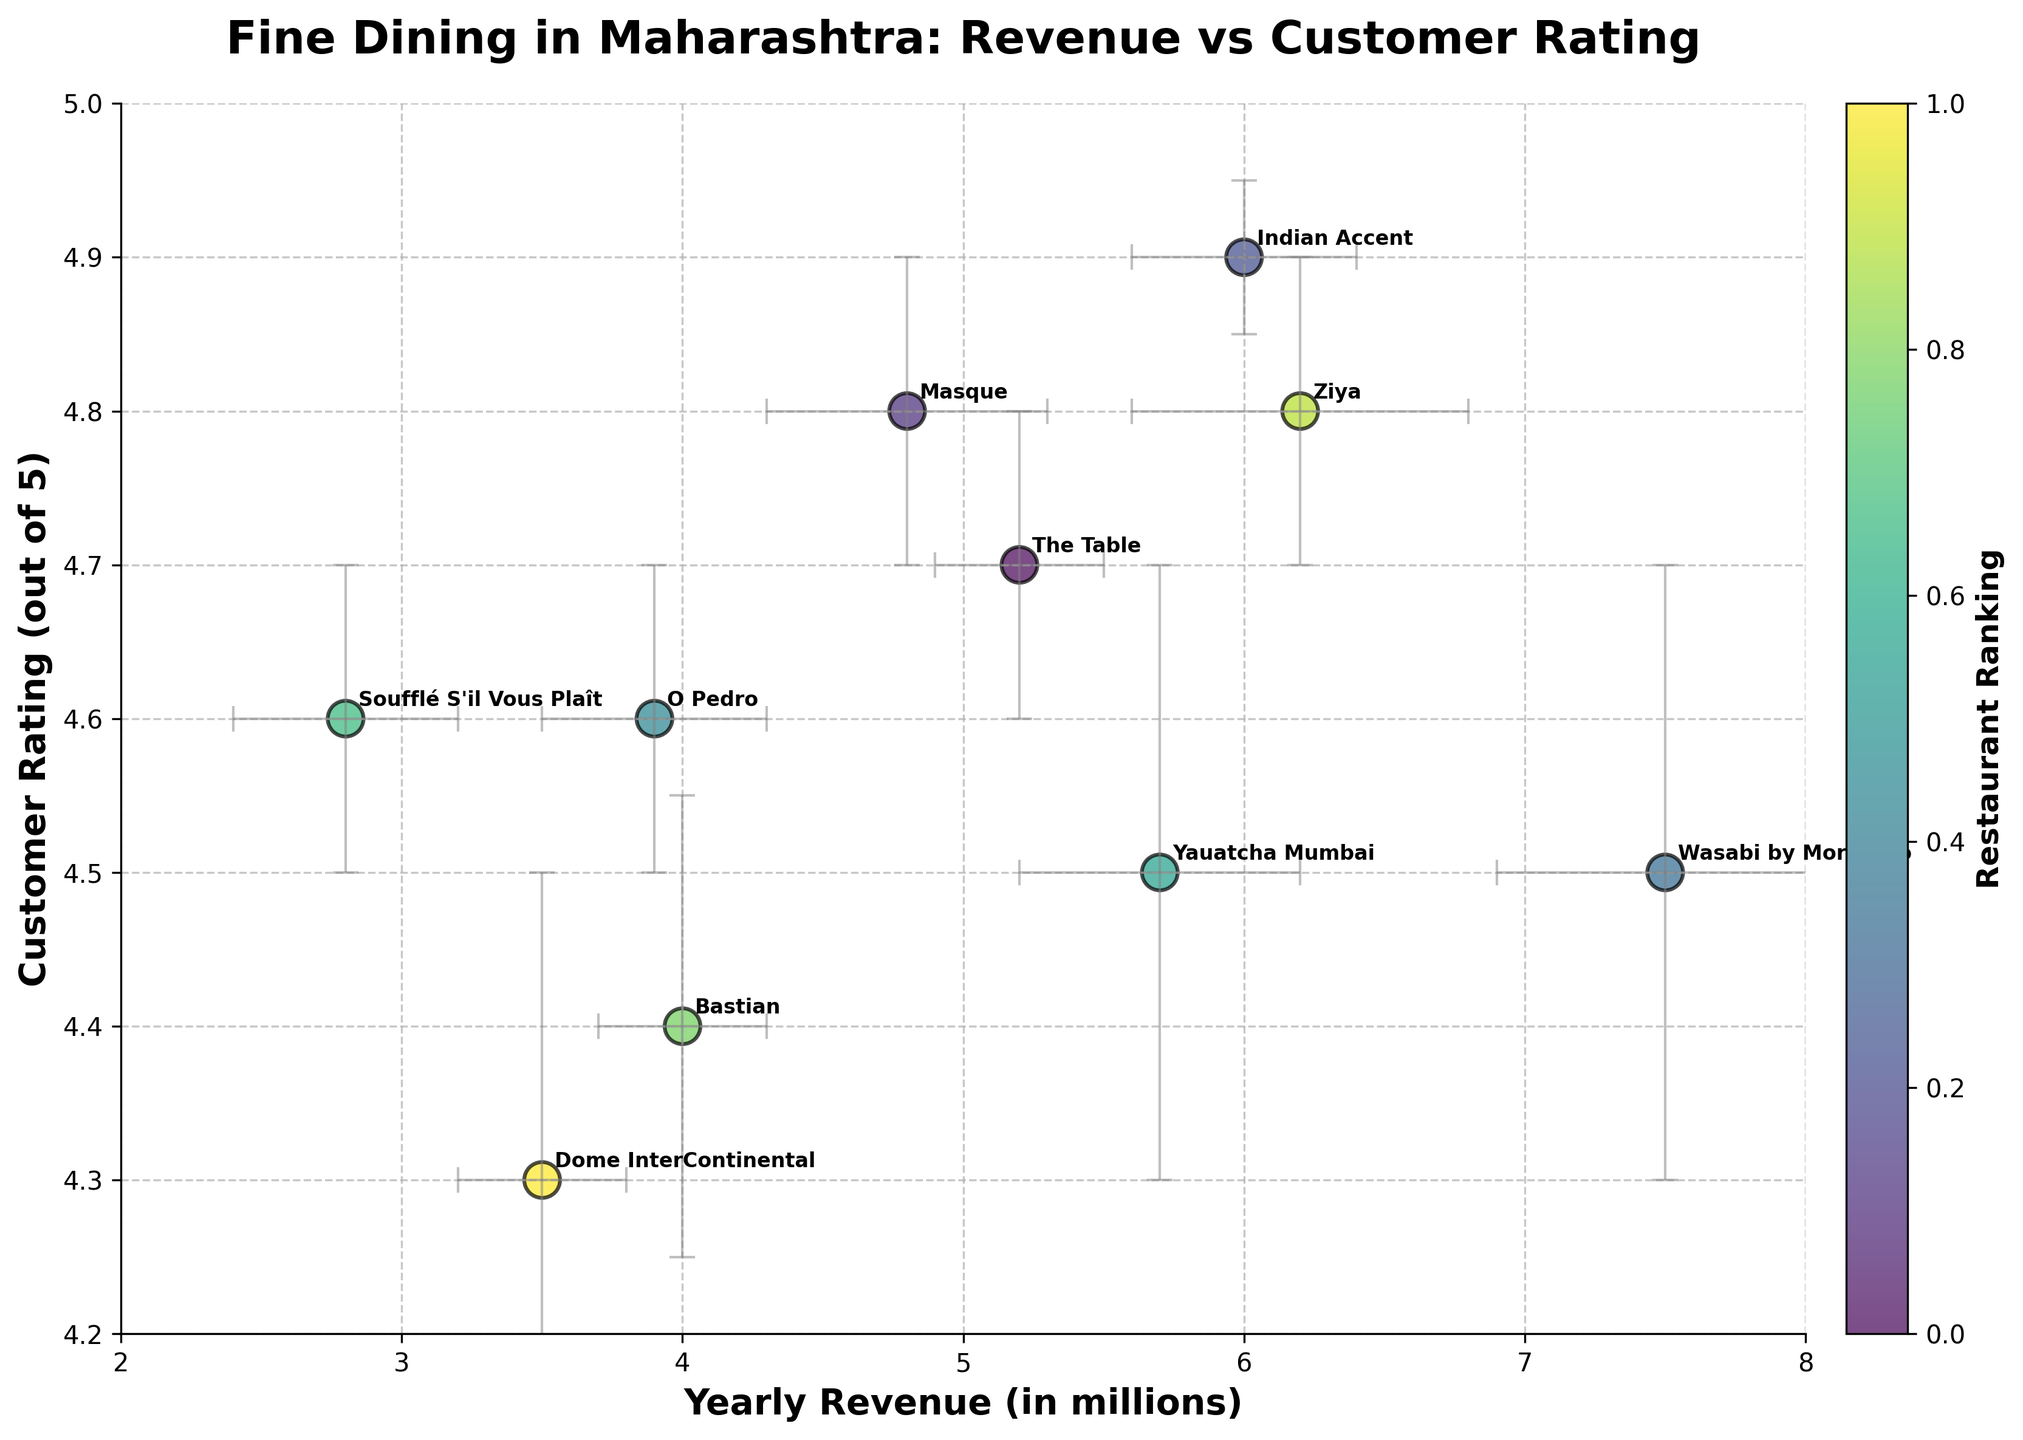What is the title of the plot? The title is typically located at the upper part of the plot. Here, it reads "Fine Dining in Maharashtra: Revenue vs Customer Rating".
Answer: Fine Dining in Maharashtra: Revenue vs Customer Rating What value range does the y-axis cover? To find the y-axis range, look at the minimum and maximum values marked along the y-axis. Here, the range is from 4.2 to 5.
Answer: 4.2 to 5 Which restaurant has the highest customer rating? Look for the restaurant with the highest y-axis value. Indian Accent, with a rating of 4.9, is positioned highest on the y-axis.
Answer: Indian Accent How many restaurants are plotted in the scatter plot? Count the number of distinct data points (including their annotations) on the plot. There are 10 unique restaurants.
Answer: 10 Which restaurant has the largest error in yearly revenue? The length of the error bars indicates the margin of error. Wasabi by Morimoto has the longest horizontal error bars, representing the largest revenue error margin of 0.6 million.
Answer: Wasabi by Morimoto What is the difference in customer rating between Ziya and Bastian? Ziya has a rating of 4.8, and Bastian has a rating of 4.4. The difference is 4.8 - 4.4 = 0.4.
Answer: 0.4 Which restaurant has both the lowest customer rating and the lowest yearly revenue? Identify the restaurant at the lowest y-axis position (customer rating) and compare their yearly revenue. Dome InterContinental has the lowest rating (4.3) and a revenue of 3.5 million.
Answer: Dome InterContinental Which restaurant, apart from The Table, has similar customer ratings but higher yearly revenue? Apart from The Table (4.7 rating), compare other restaurants with similar customer ratings and higher revenues. Indian Accent, with a 4.9 rating and 6.0 million revenue, is a correct match.
Answer: Indian Accent What trends can you observe about the relationship between yearly revenue and customer rating? Generally, higher customer ratings seem to be associated with varied revenue levels but do not show a direct linear correlation. For example, Indian Accent has a high rating and revenue, while O Pedro has a relatively high rating but lower revenue.
Answer: Varied correlation What impact do error margins have on interpreting the restaurant data? Error margins introduce uncertainty, indicated by the size of the error bars. Larger error bars, like for Wasabi by Morimoto, suggest higher variability in data reliability, making it crucial to consider these margins when interpreting the plotted values.
Answer: Significance of data variability 